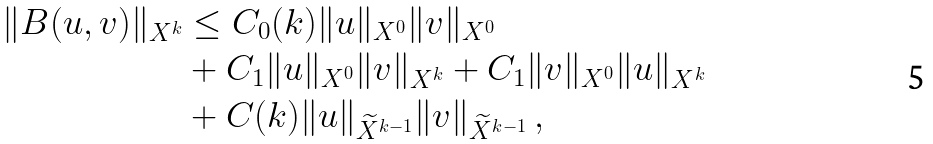Convert formula to latex. <formula><loc_0><loc_0><loc_500><loc_500>\| B ( u , v ) \| _ { X ^ { k } } & \leq C _ { 0 } ( k ) \| u \| _ { X ^ { 0 } } \| v \| _ { X ^ { 0 } } \\ & + C _ { 1 } \| u \| _ { X ^ { 0 } } \| v \| _ { X ^ { k } } + C _ { 1 } \| v \| _ { X ^ { 0 } } \| u \| _ { X ^ { k } } \\ & + C ( k ) \| u \| _ { \widetilde { X } ^ { k - 1 } } \| v \| _ { \widetilde { X } ^ { k - 1 } } \, ,</formula> 